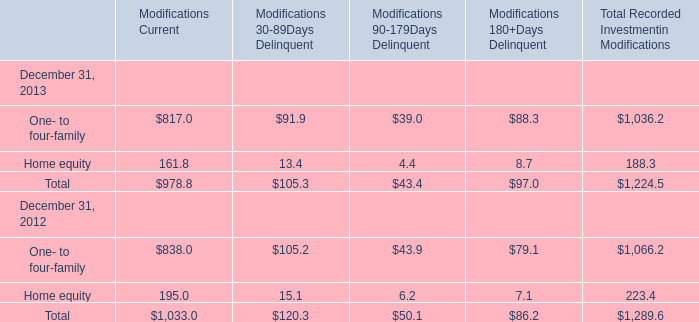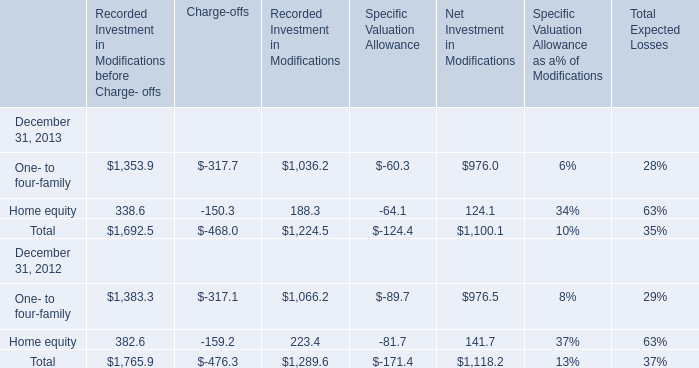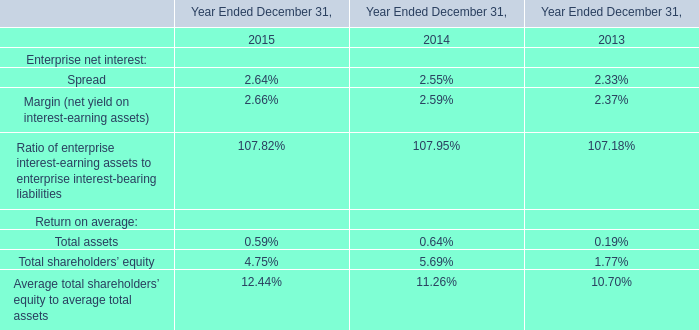In which year is One- to four-family's Recorded Investment in Modifications before Charge- offs positive? 
Answer: 2012,2013. 